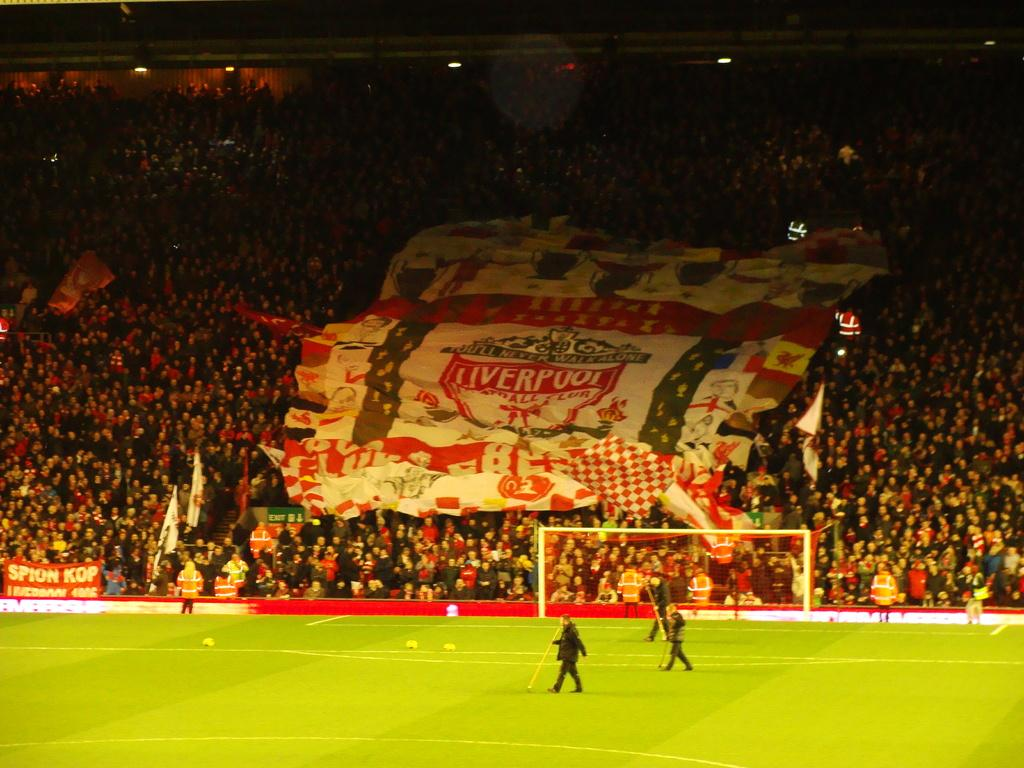Provide a one-sentence caption for the provided image. Fans hold up a large flag for the sports team from Liverpool. 